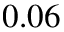Convert formula to latex. <formula><loc_0><loc_0><loc_500><loc_500>0 . 0 6</formula> 